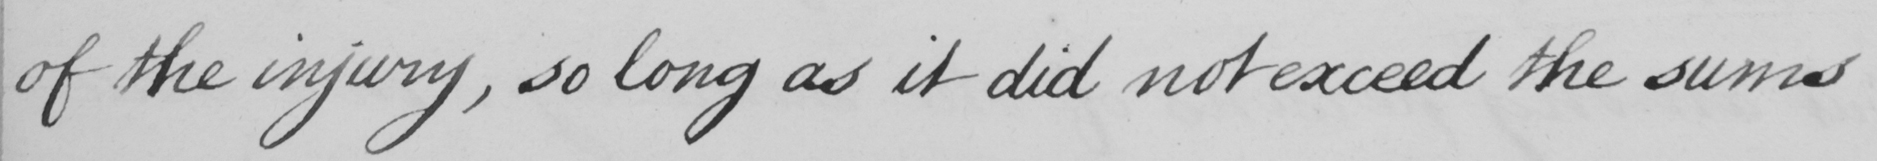Please provide the text content of this handwritten line. of the injury , so long as it did not exceed the sums 